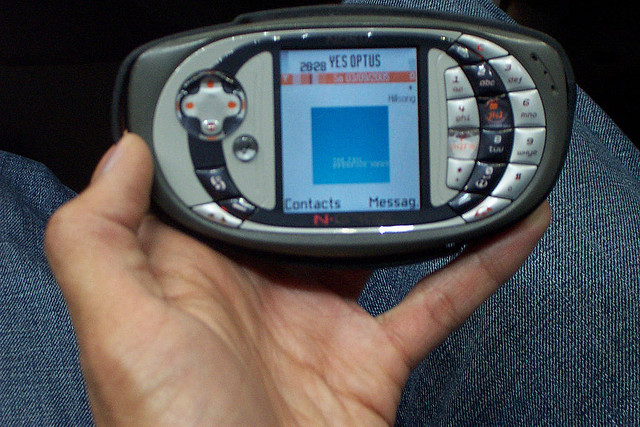Identify and read out the text in this image. YES OPTUS 2028 Contacts Messag 